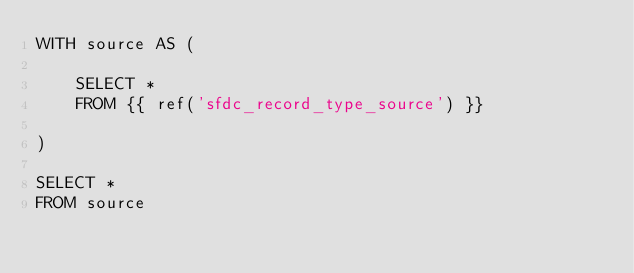Convert code to text. <code><loc_0><loc_0><loc_500><loc_500><_SQL_>WITH source AS (

    SELECT *
    FROM {{ ref('sfdc_record_type_source') }}

)

SELECT *
FROM source
</code> 